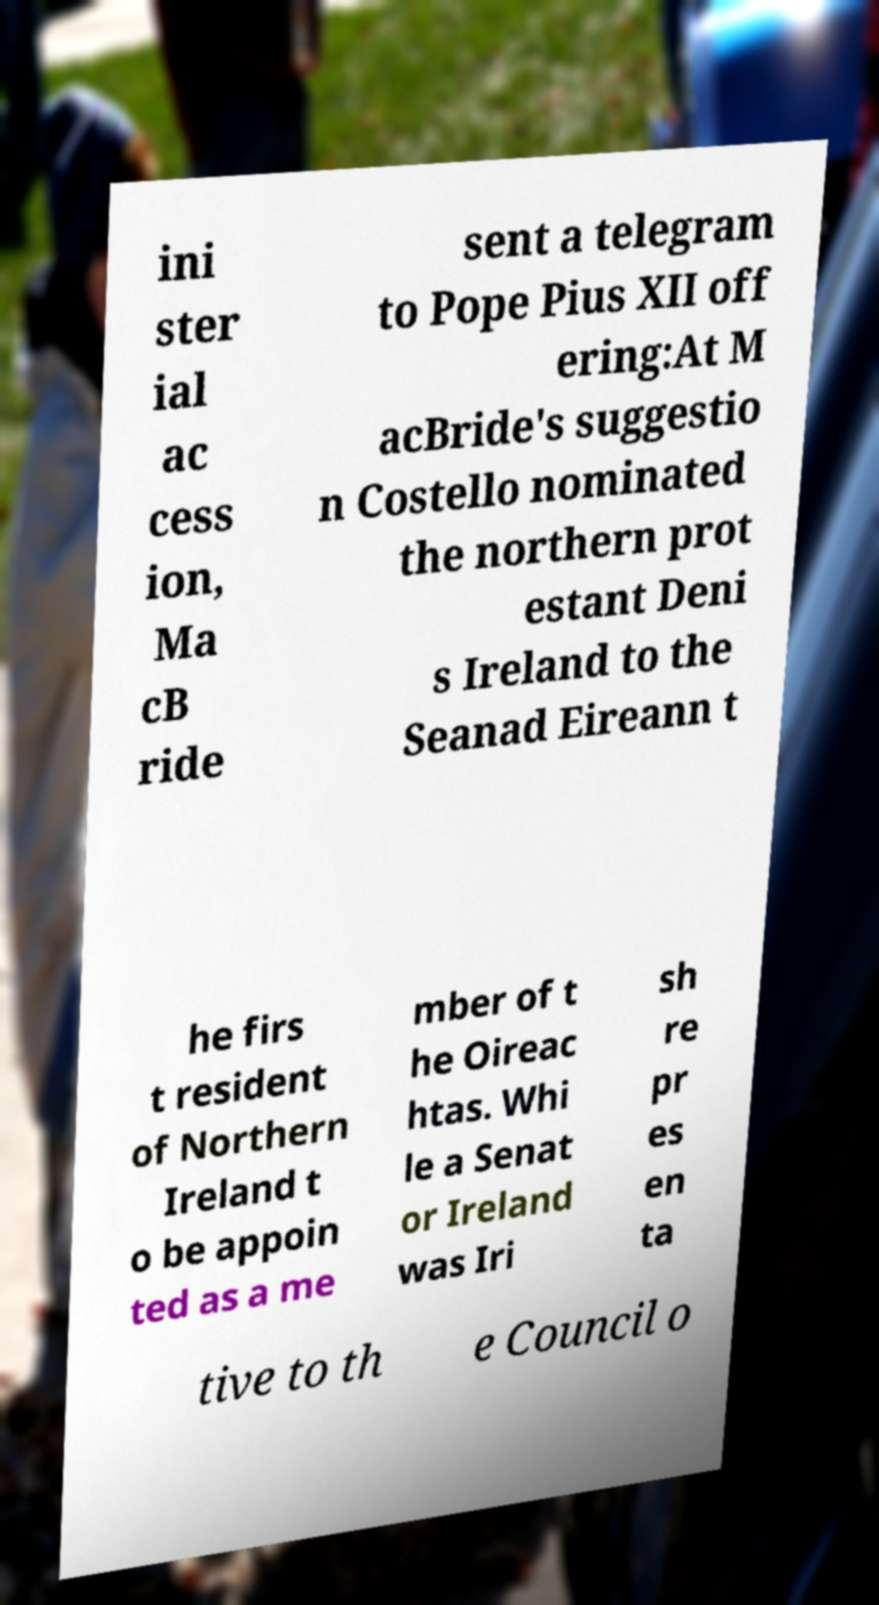For documentation purposes, I need the text within this image transcribed. Could you provide that? ini ster ial ac cess ion, Ma cB ride sent a telegram to Pope Pius XII off ering:At M acBride's suggestio n Costello nominated the northern prot estant Deni s Ireland to the Seanad Eireann t he firs t resident of Northern Ireland t o be appoin ted as a me mber of t he Oireac htas. Whi le a Senat or Ireland was Iri sh re pr es en ta tive to th e Council o 